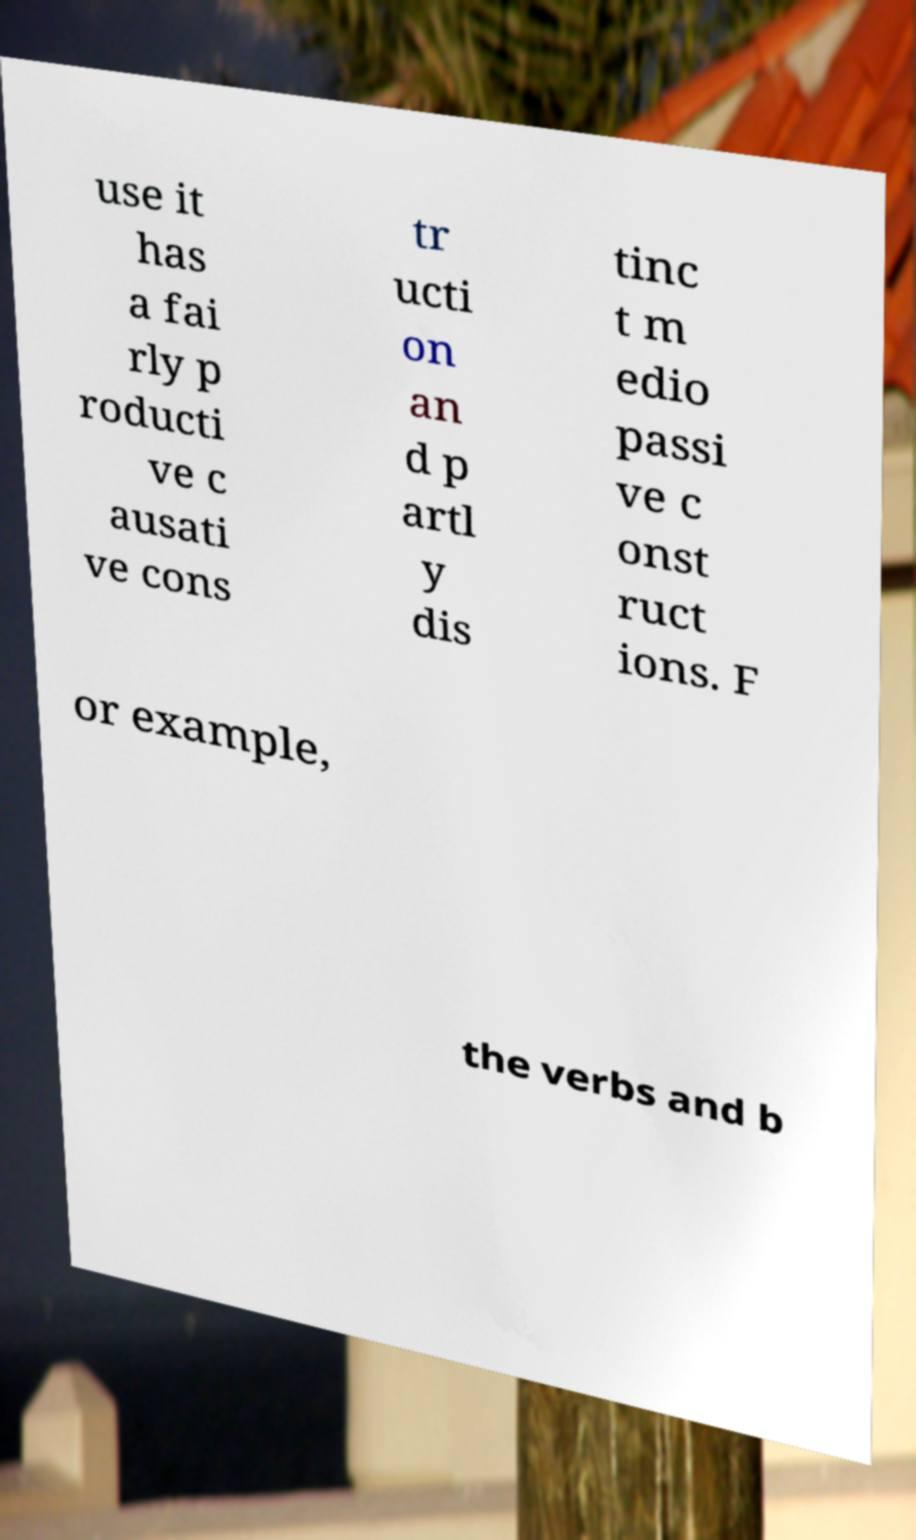Can you accurately transcribe the text from the provided image for me? use it has a fai rly p roducti ve c ausati ve cons tr ucti on an d p artl y dis tinc t m edio passi ve c onst ruct ions. F or example, the verbs and b 